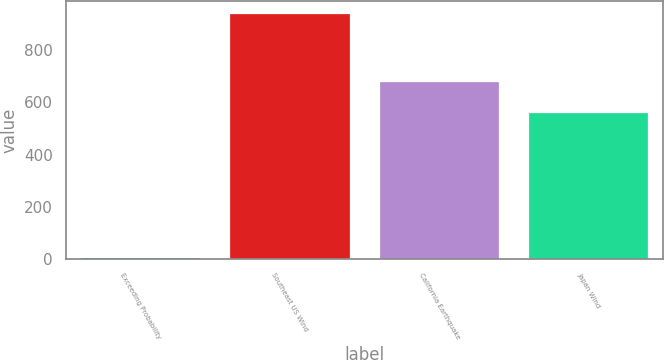<chart> <loc_0><loc_0><loc_500><loc_500><bar_chart><fcel>Exceeding Probability<fcel>Southeast US Wind<fcel>California Earthquake<fcel>Japan Wind<nl><fcel>1<fcel>941<fcel>678<fcel>560<nl></chart> 